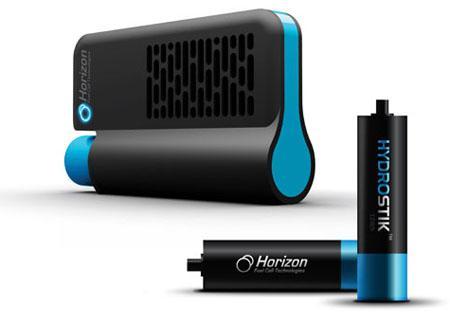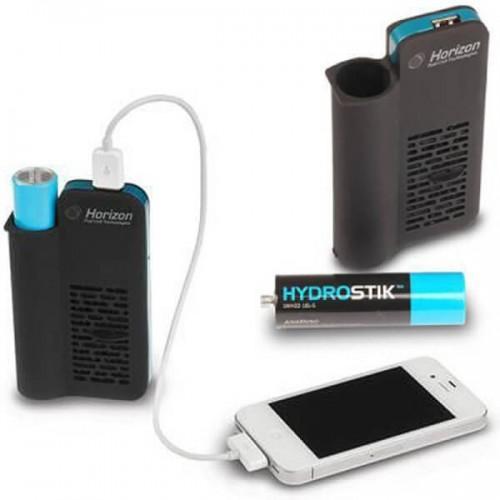The first image is the image on the left, the second image is the image on the right. Analyze the images presented: Is the assertion "The right image shows a flat rectangular device with a cord in it, next to a charging device with the other end of the cord in it." valid? Answer yes or no. Yes. The first image is the image on the left, the second image is the image on the right. Evaluate the accuracy of this statement regarding the images: "There are three devices.". Is it true? Answer yes or no. No. 